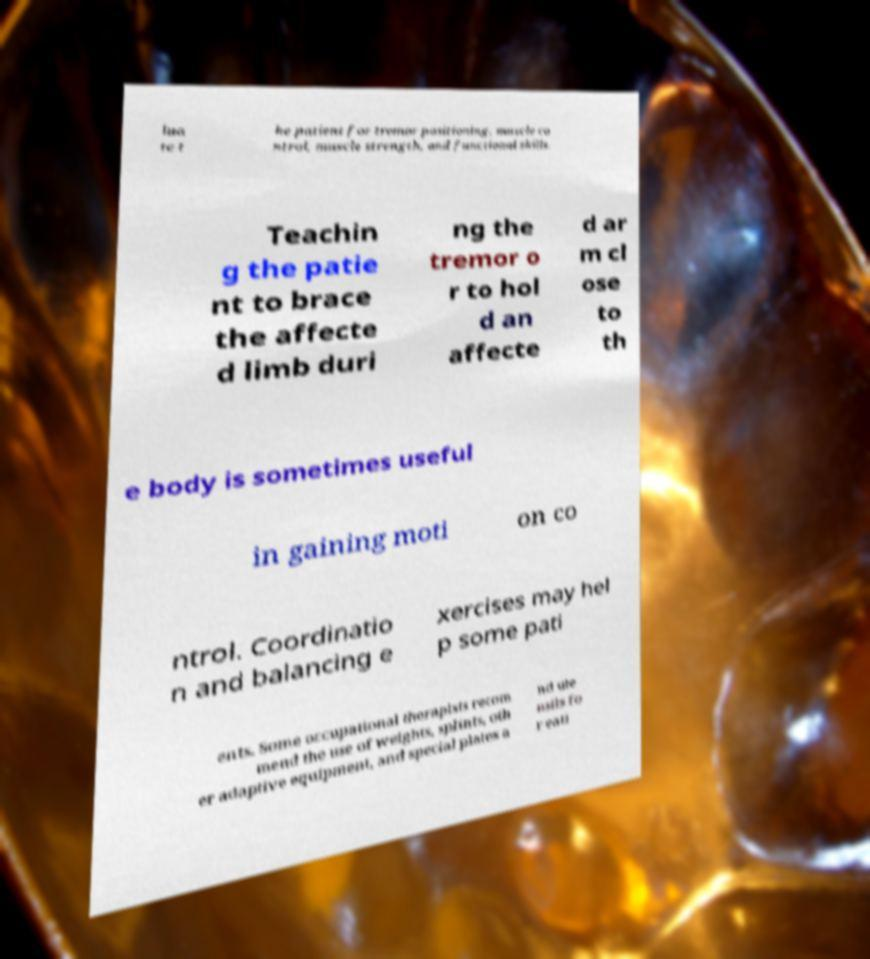There's text embedded in this image that I need extracted. Can you transcribe it verbatim? lua te t he patient for tremor positioning, muscle co ntrol, muscle strength, and functional skills. Teachin g the patie nt to brace the affecte d limb duri ng the tremor o r to hol d an affecte d ar m cl ose to th e body is sometimes useful in gaining moti on co ntrol. Coordinatio n and balancing e xercises may hel p some pati ents. Some occupational therapists recom mend the use of weights, splints, oth er adaptive equipment, and special plates a nd ute nsils fo r eati 